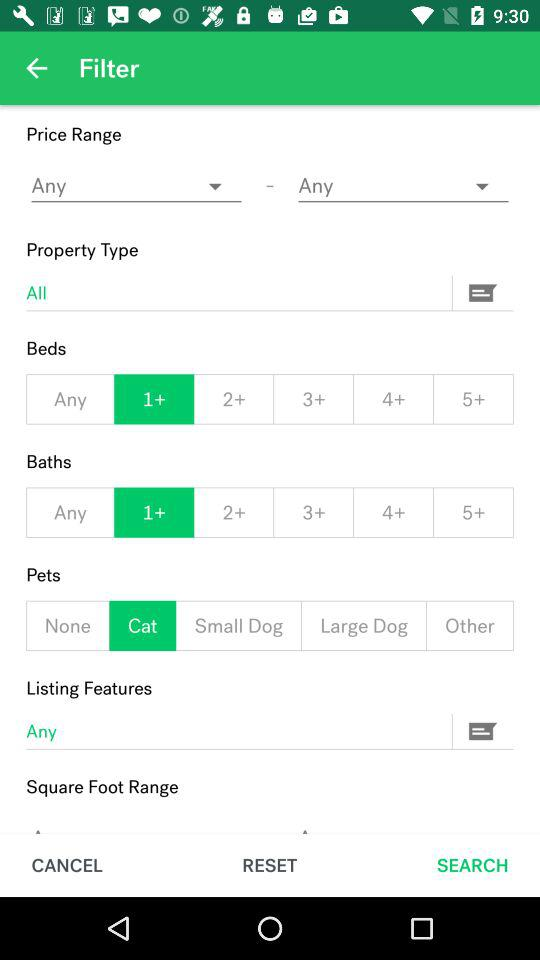What kind of property type was chosen? The chosen property type was "All". 